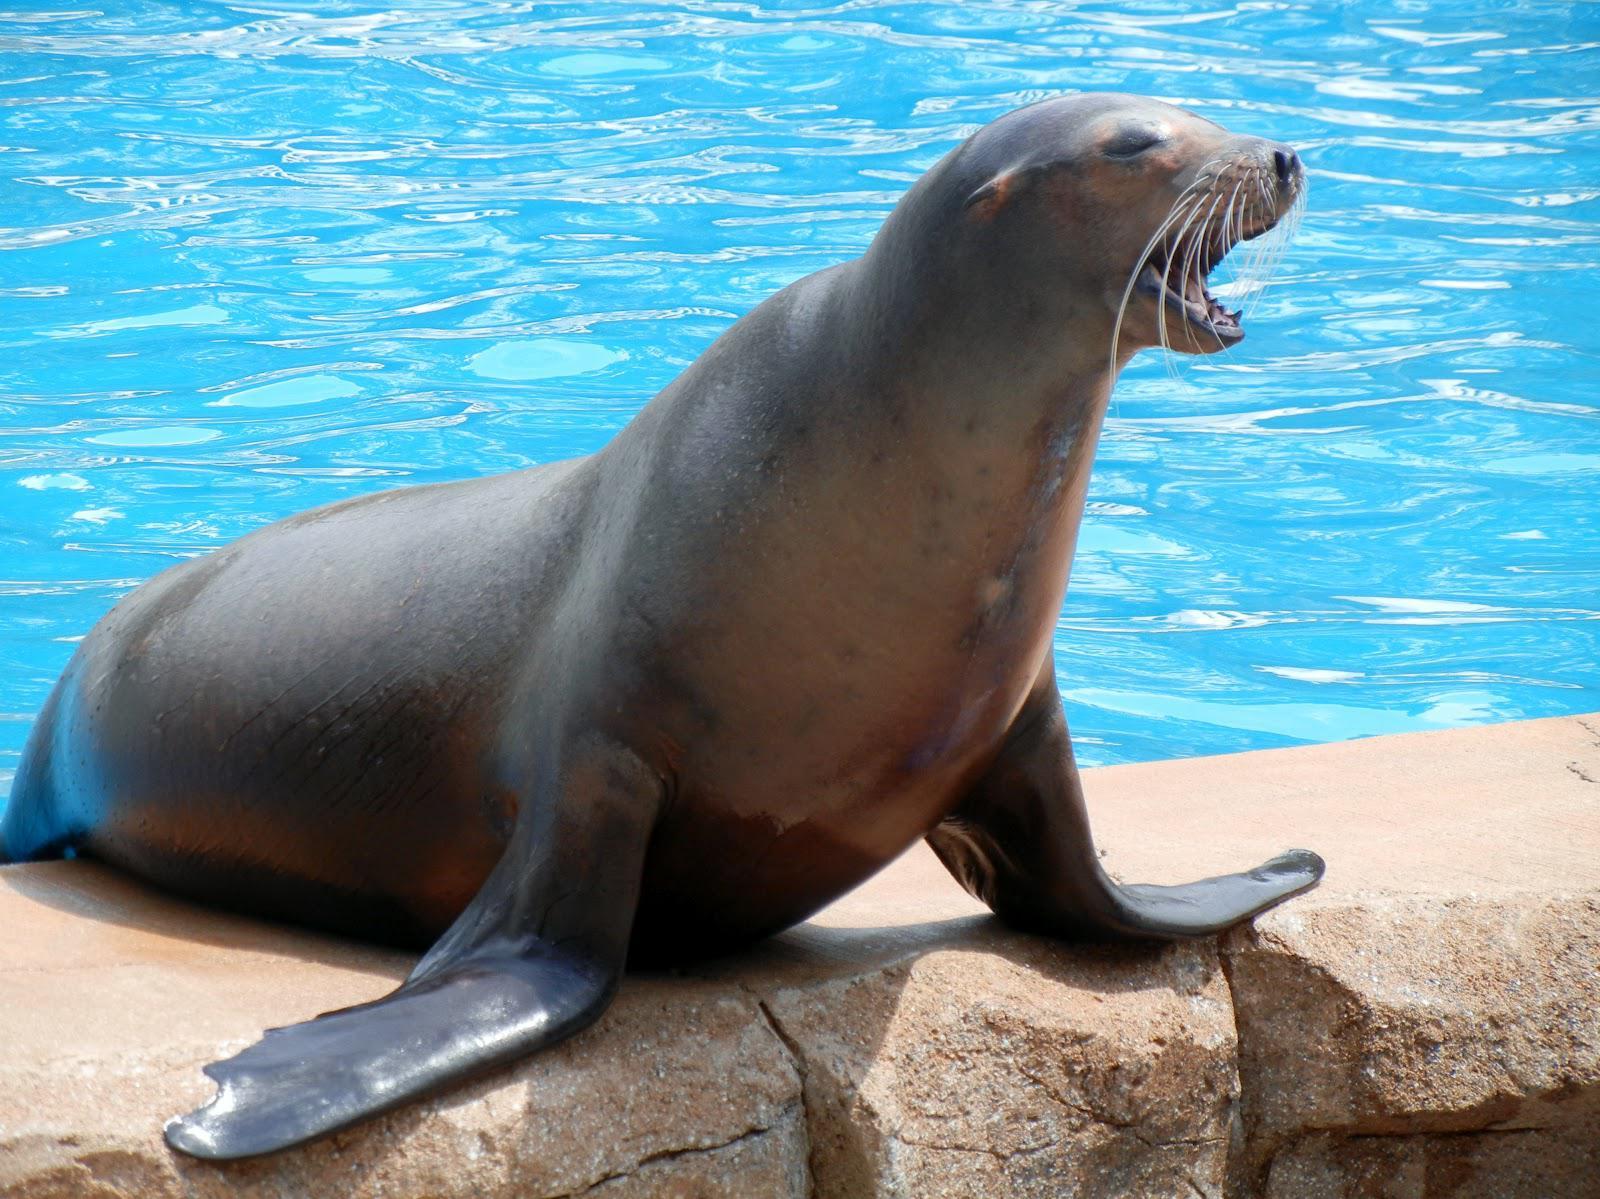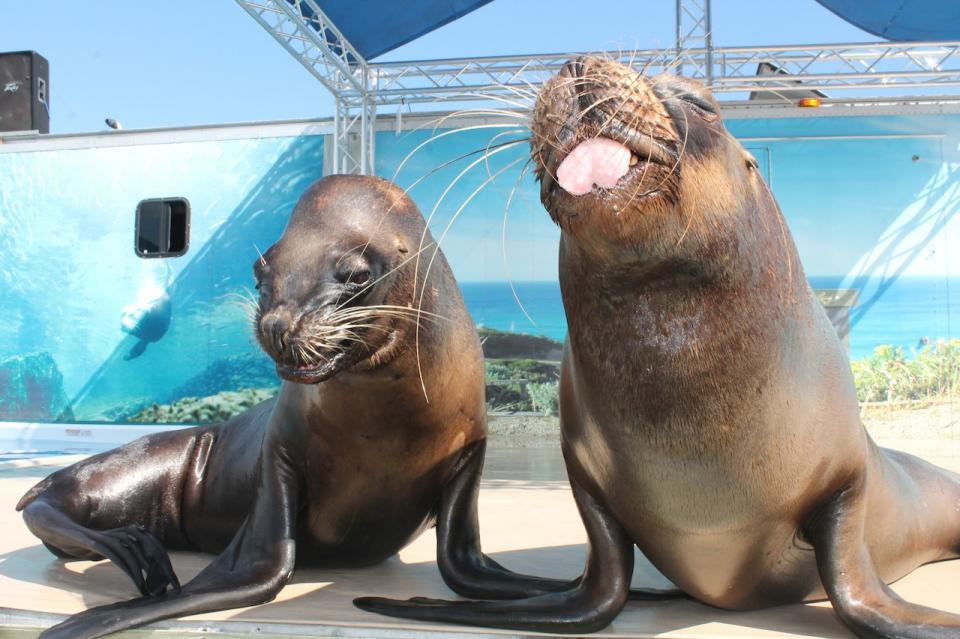The first image is the image on the left, the second image is the image on the right. Assess this claim about the two images: "Each image shows exactly one seal with raised head and water in the background, and one of the depicted seals faces left, while the other faces right.". Correct or not? Answer yes or no. No. The first image is the image on the left, the second image is the image on the right. Evaluate the accuracy of this statement regarding the images: "The right image contains at least two seals.". Is it true? Answer yes or no. Yes. 